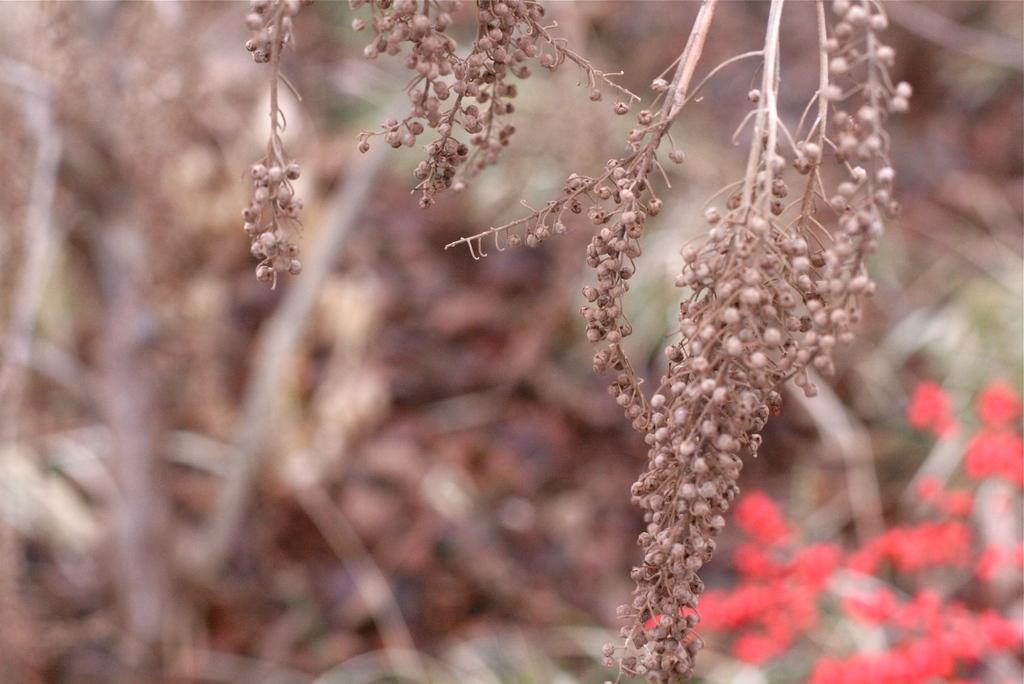Could you give a brief overview of what you see in this image? In this image I can see planets and the background is blurred. 